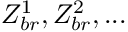<formula> <loc_0><loc_0><loc_500><loc_500>Z _ { b r } ^ { 1 } , Z _ { b r } ^ { 2 } , \dots</formula> 